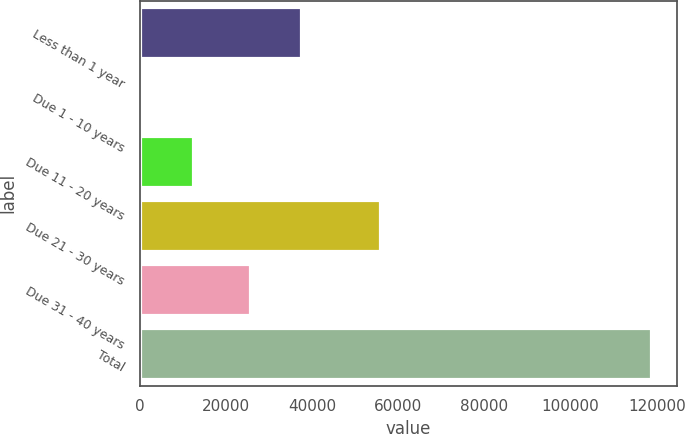Convert chart. <chart><loc_0><loc_0><loc_500><loc_500><bar_chart><fcel>Less than 1 year<fcel>Due 1 - 10 years<fcel>Due 11 - 20 years<fcel>Due 21 - 30 years<fcel>Due 31 - 40 years<fcel>Total<nl><fcel>37344<fcel>662<fcel>12467<fcel>55881<fcel>25539<fcel>118712<nl></chart> 